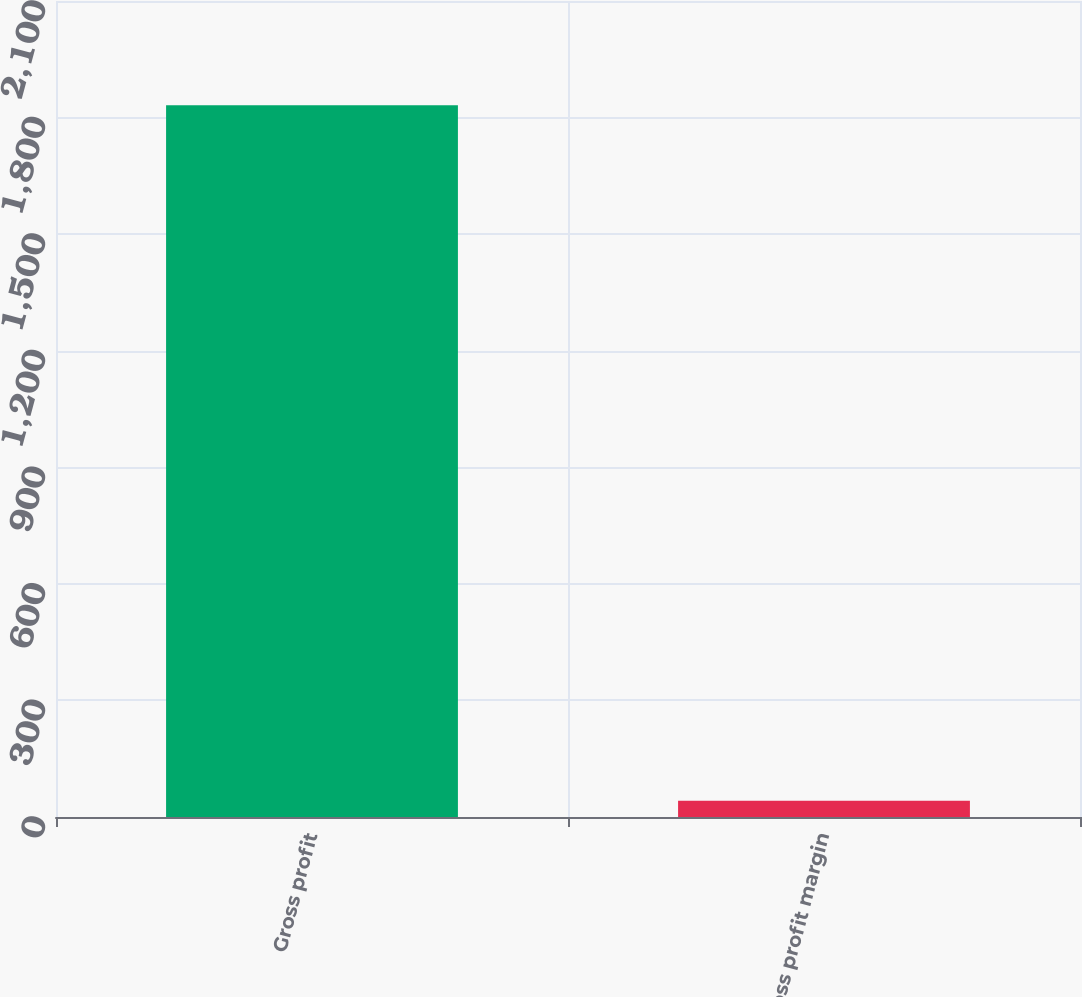<chart> <loc_0><loc_0><loc_500><loc_500><bar_chart><fcel>Gross profit<fcel>Gross profit margin<nl><fcel>1831.7<fcel>41.5<nl></chart> 